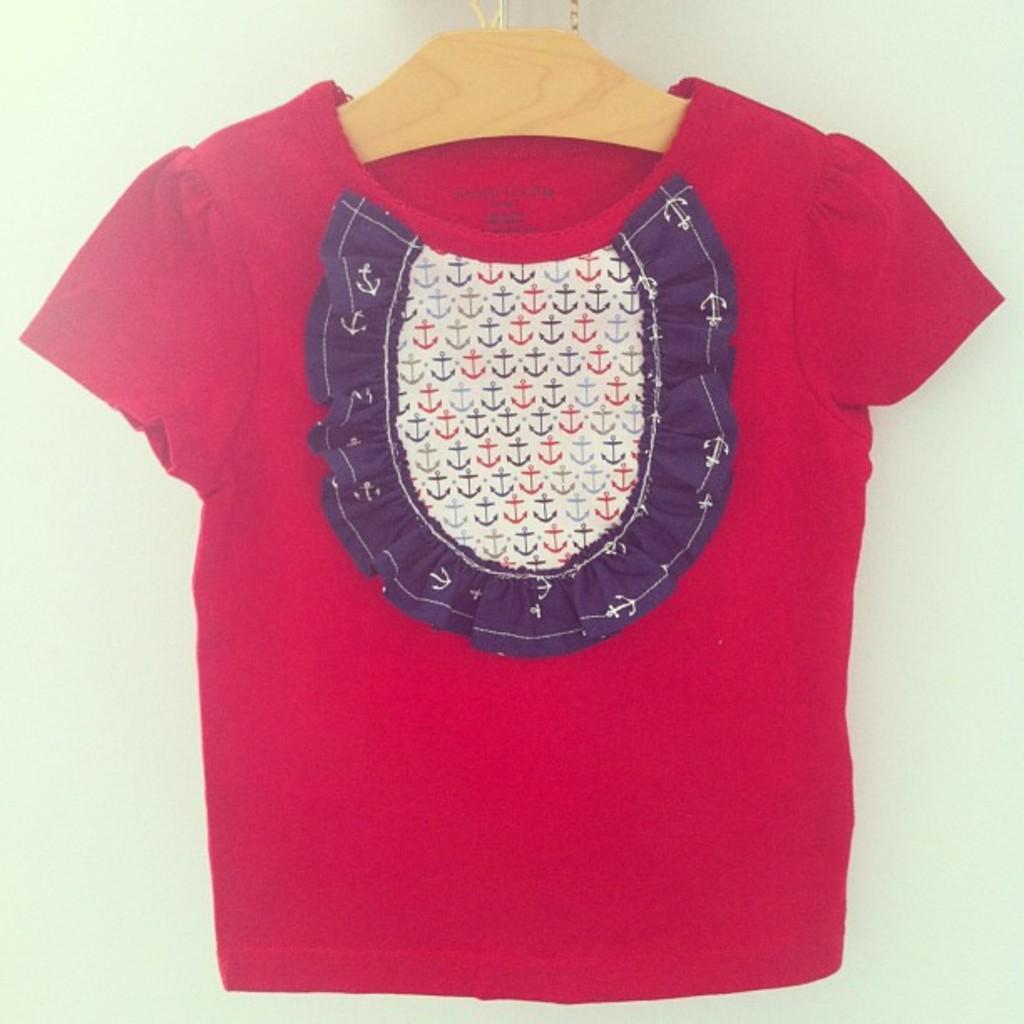In one or two sentences, can you explain what this image depicts? In this image I can see a red colour cloth on a cream colour hanger. 